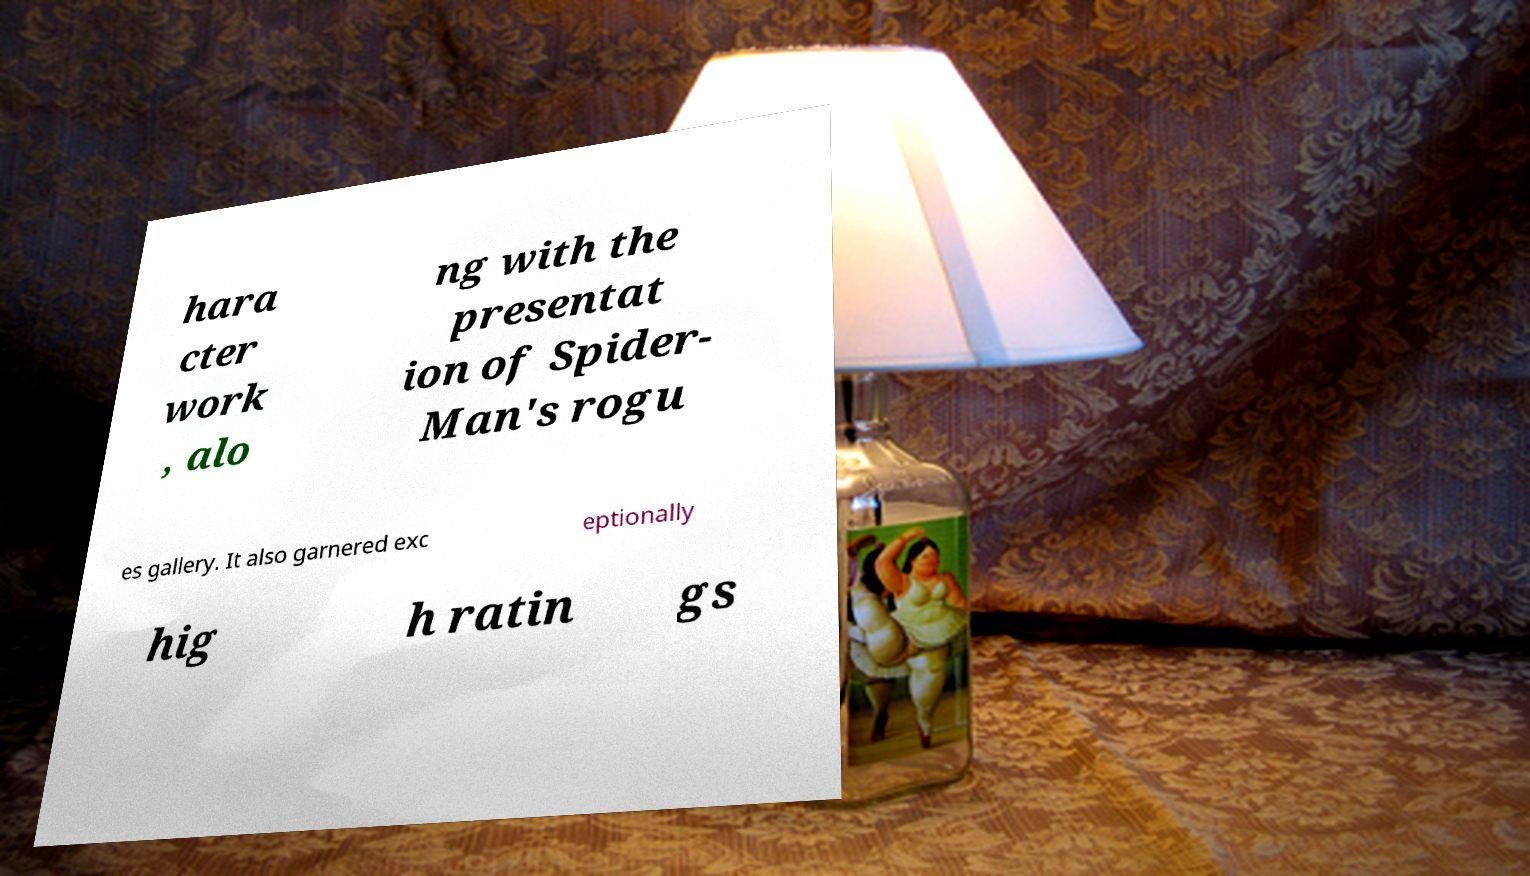Please identify and transcribe the text found in this image. hara cter work , alo ng with the presentat ion of Spider- Man's rogu es gallery. It also garnered exc eptionally hig h ratin gs 